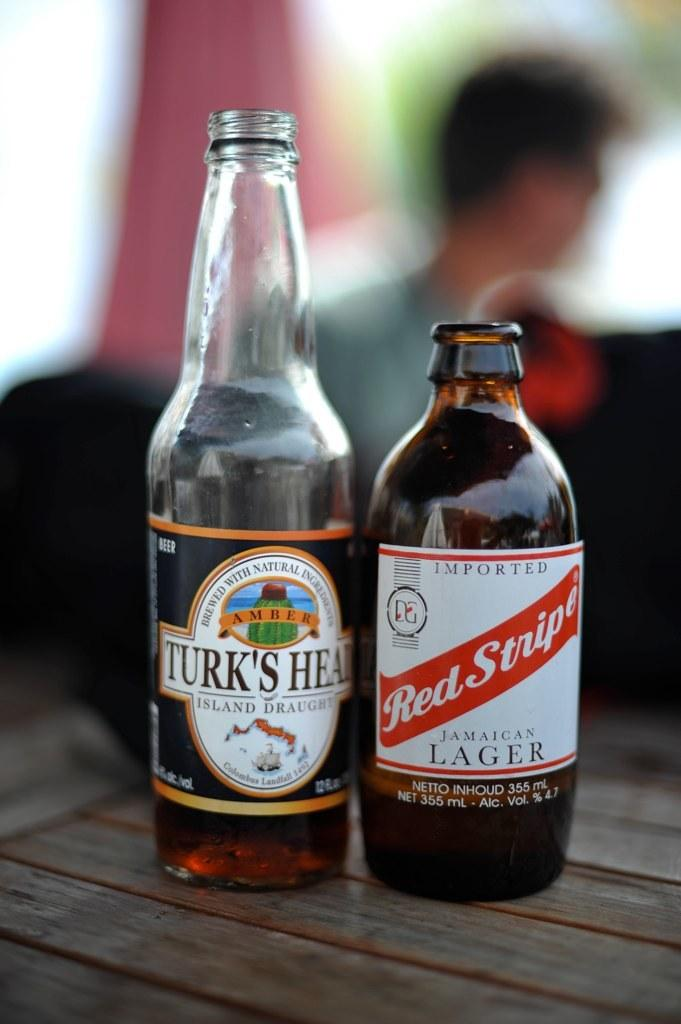<image>
Describe the image concisely. A bottle of Turk's head and red stripe Jamaican Lager. 